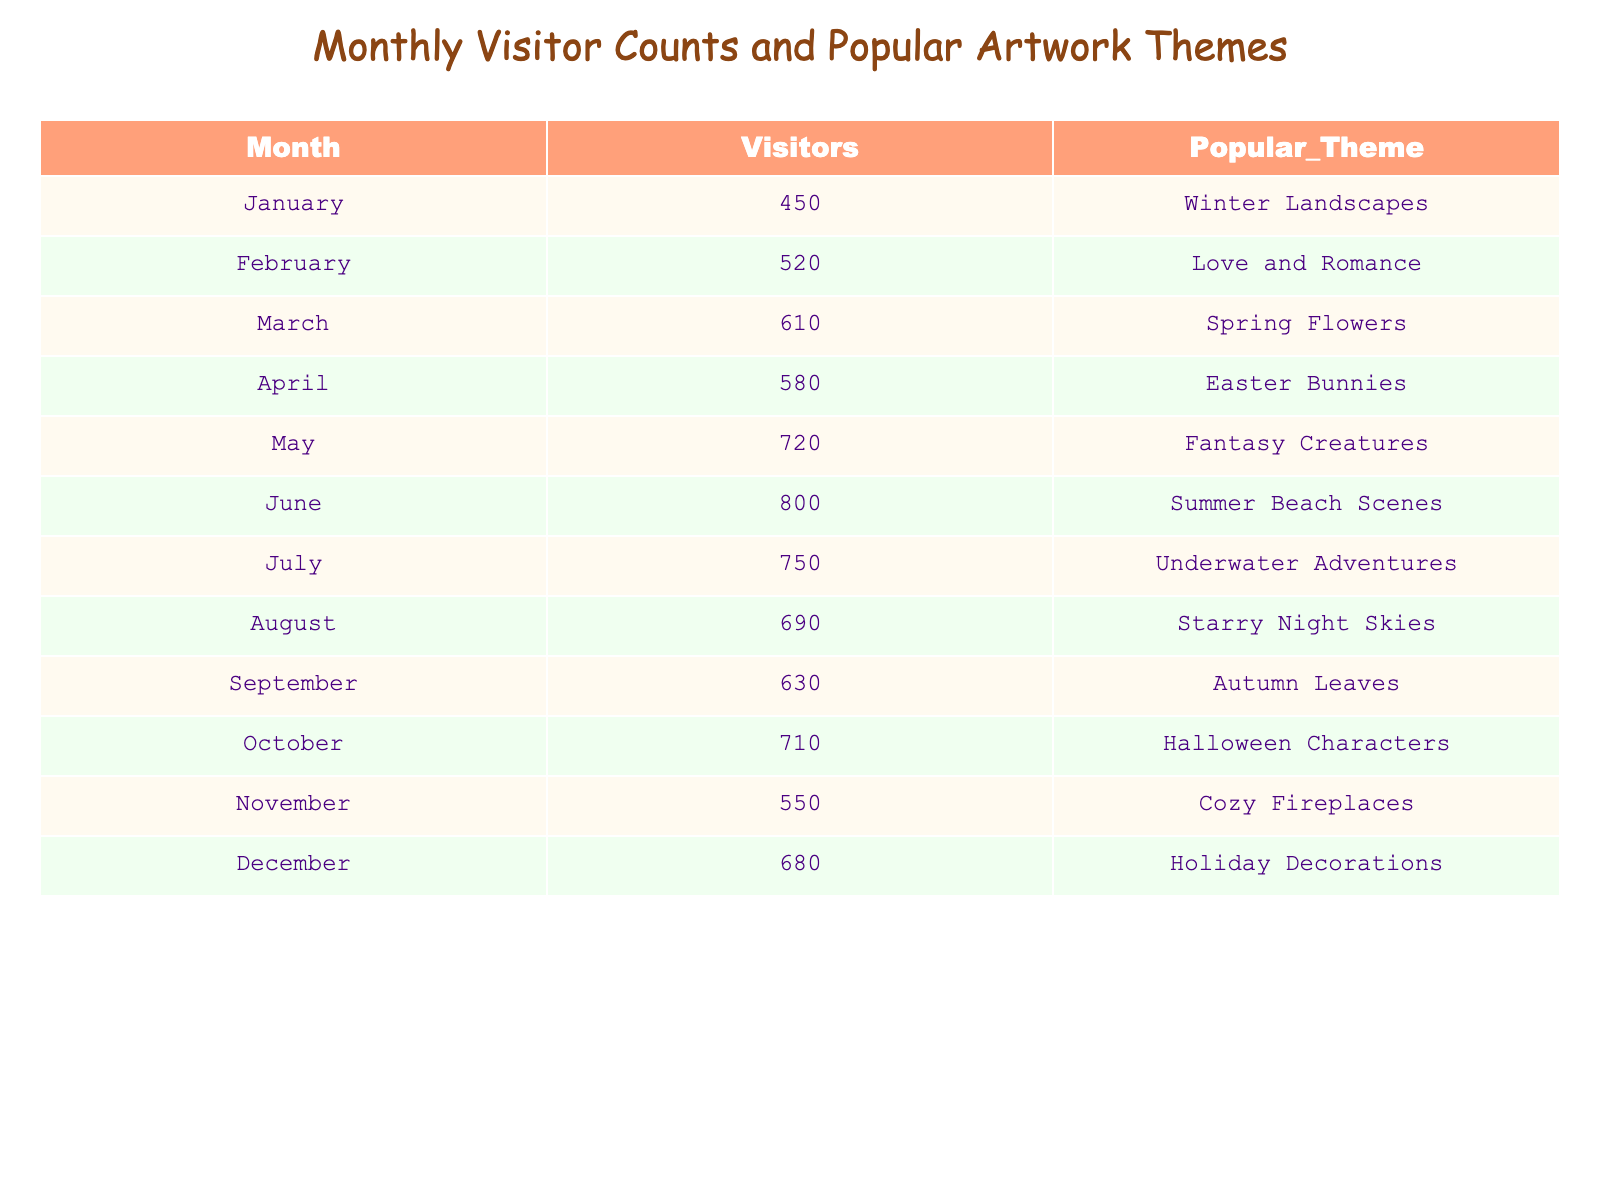What is the most popular artwork theme in June? The table indicates that the popular theme for June is "Summer Beach Scenes" as mentioned in the corresponding row for that month.
Answer: Summer Beach Scenes How many visitors were there in November? The table shows that the number of visitors in November is 550, found in the corresponding row.
Answer: 550 Which month had the highest visitor count? By examining the visitor counts, June has the highest number at 800, which is greater than all other months listed.
Answer: June What is the average number of visitors across all months? To find the average, sum the visitor counts (450 + 520 + 610 + 580 + 720 + 800 + 750 + 690 + 630 + 710 + 550 + 680 = 7,490) and divide by the total number of months (12). Therefore, the average is 7,490 / 12 ≈ 624.17.
Answer: 624.17 Was "Fantasy Creatures" the most popular theme of the year? Looking at the themes in the table, we find that while "Fantasy Creatures" was popular in May, it was not the most popular throughout the year, as other themes were also present in the popular themes list.
Answer: No What is the difference in visitor counts between the highest and lowest month? The highest count is 800 (June), while the lowest is 450 (January). The difference is 800 - 450 = 350.
Answer: 350 In which month does "Holiday Decorations" appear as the popular theme? The table shows that "Holiday Decorations" is the popular theme for December, as detailed in the row for that month.
Answer: December How many more visitors did July have compared to September? July recorded 750 visitors, while September had 630. The difference is 750 - 630 = 120 more visitors in July.
Answer: 120 Which months have a visitor count greater than 600? The months with visitor counts greater than 600 are March (610), May (720), June (800), July (750), October (710), and December (680), found by checking each month’s visitor total.
Answer: March, May, June, July, October, December Is there a month when "Cozy Fireplaces" is the popular theme? Yes, the table confirms that "Cozy Fireplaces" is the popular theme for November, as seen in that month's row.
Answer: Yes 